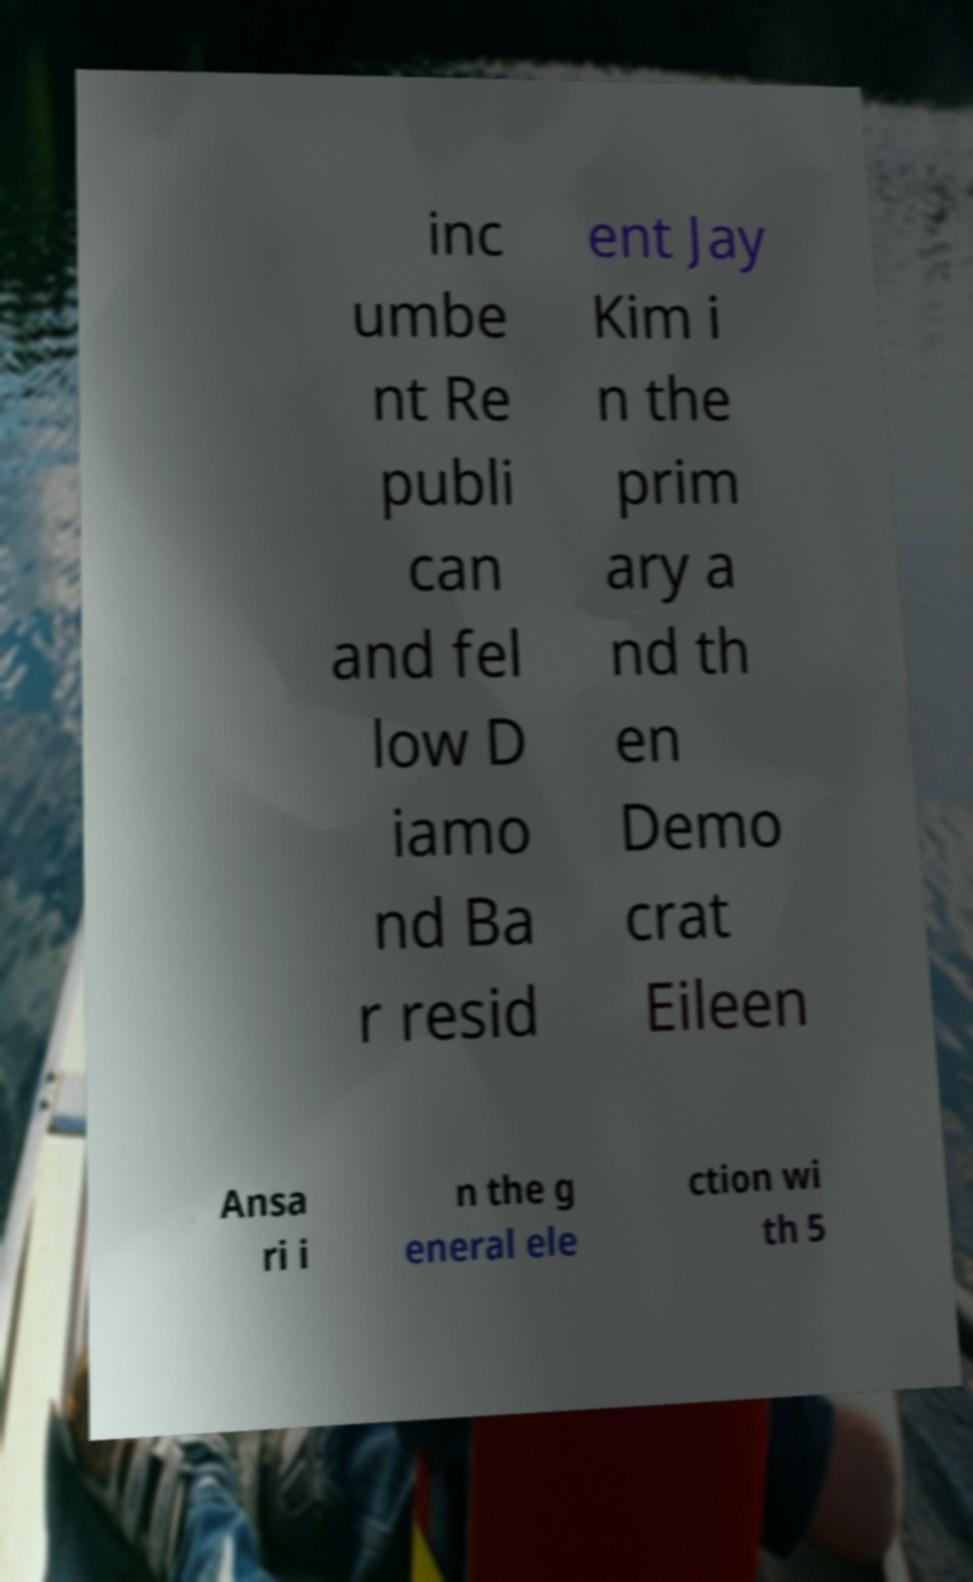I need the written content from this picture converted into text. Can you do that? inc umbe nt Re publi can and fel low D iamo nd Ba r resid ent Jay Kim i n the prim ary a nd th en Demo crat Eileen Ansa ri i n the g eneral ele ction wi th 5 